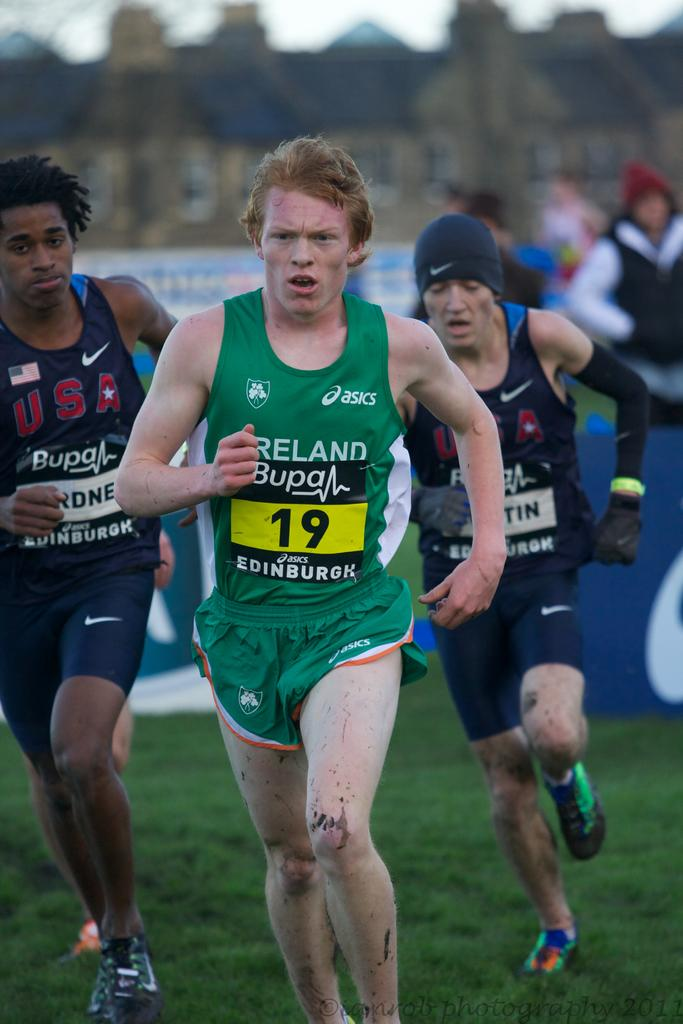<image>
Provide a brief description of the given image. a person running with the number 19 on them 